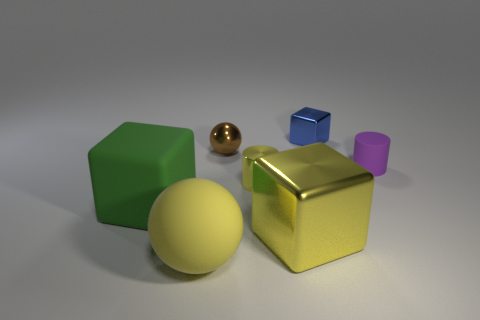Can you tell me what colors the different objects in the image have? Certainly! In the image, there is a diversity of colors: the large object on the right is a shiny gold-yellow cube. To its left, there is a large dull green hexahedron, and a medium-sized gold-brown spherical object is in front. Behind these, we see a small blue cube and a tiny purple cylinder. 